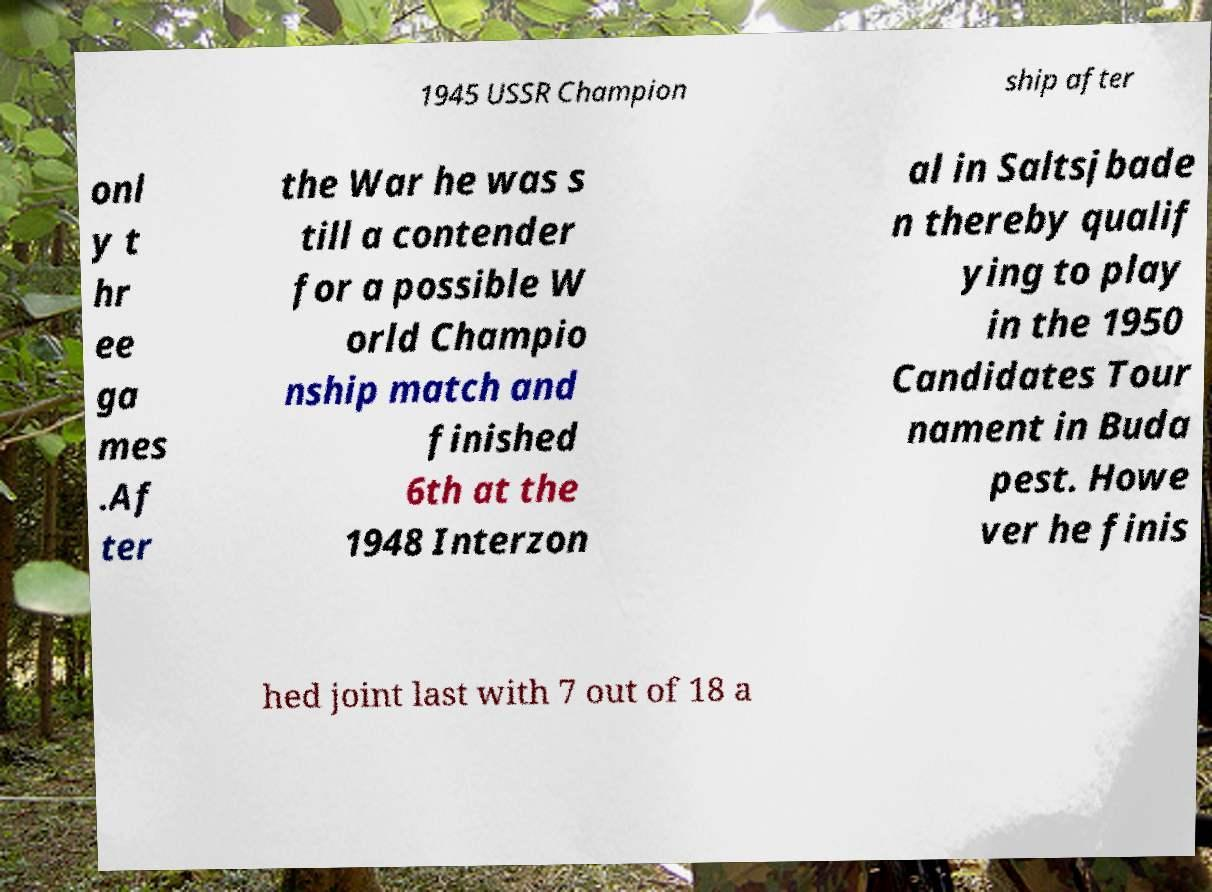Could you assist in decoding the text presented in this image and type it out clearly? 1945 USSR Champion ship after onl y t hr ee ga mes .Af ter the War he was s till a contender for a possible W orld Champio nship match and finished 6th at the 1948 Interzon al in Saltsjbade n thereby qualif ying to play in the 1950 Candidates Tour nament in Buda pest. Howe ver he finis hed joint last with 7 out of 18 a 